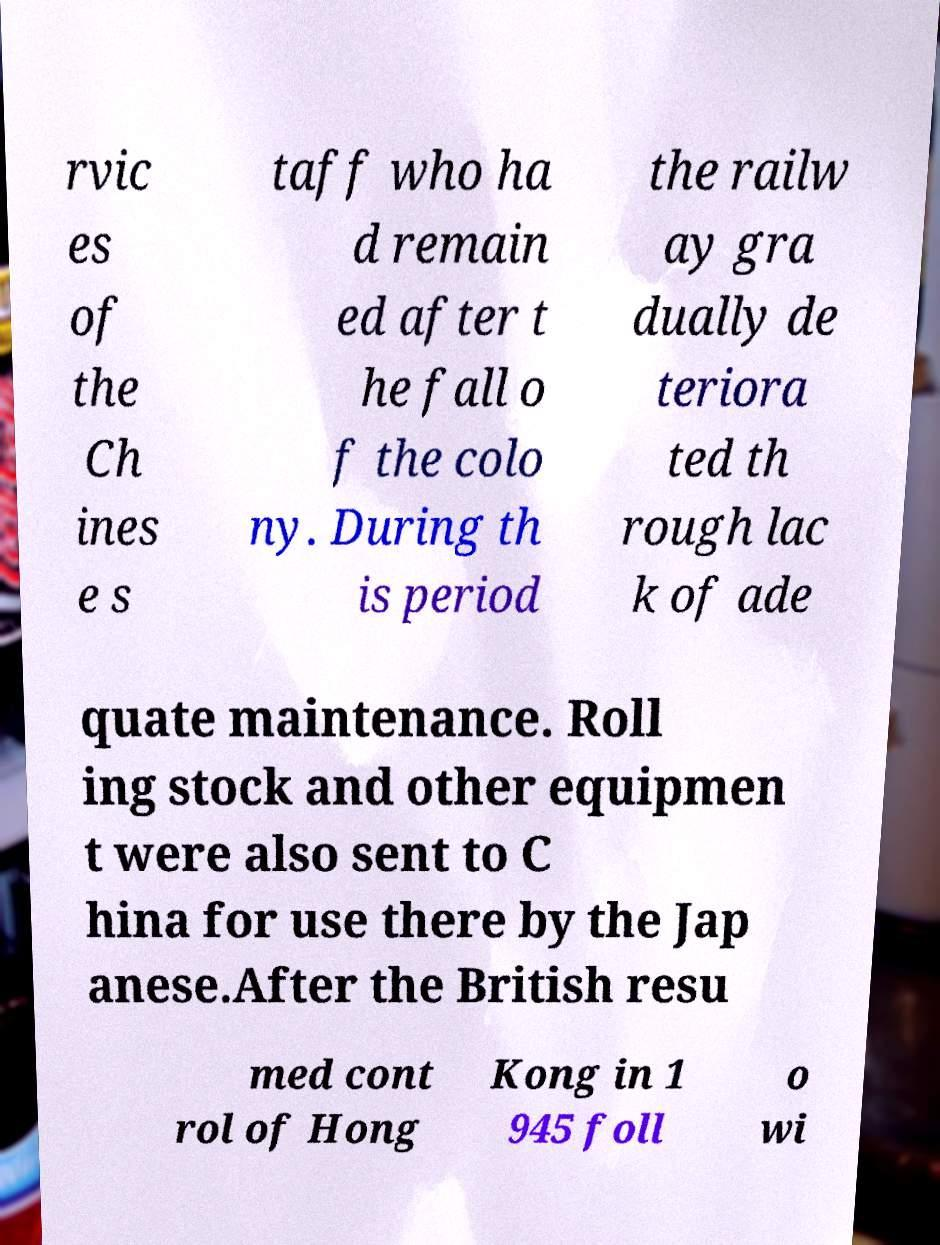Can you read and provide the text displayed in the image?This photo seems to have some interesting text. Can you extract and type it out for me? rvic es of the Ch ines e s taff who ha d remain ed after t he fall o f the colo ny. During th is period the railw ay gra dually de teriora ted th rough lac k of ade quate maintenance. Roll ing stock and other equipmen t were also sent to C hina for use there by the Jap anese.After the British resu med cont rol of Hong Kong in 1 945 foll o wi 